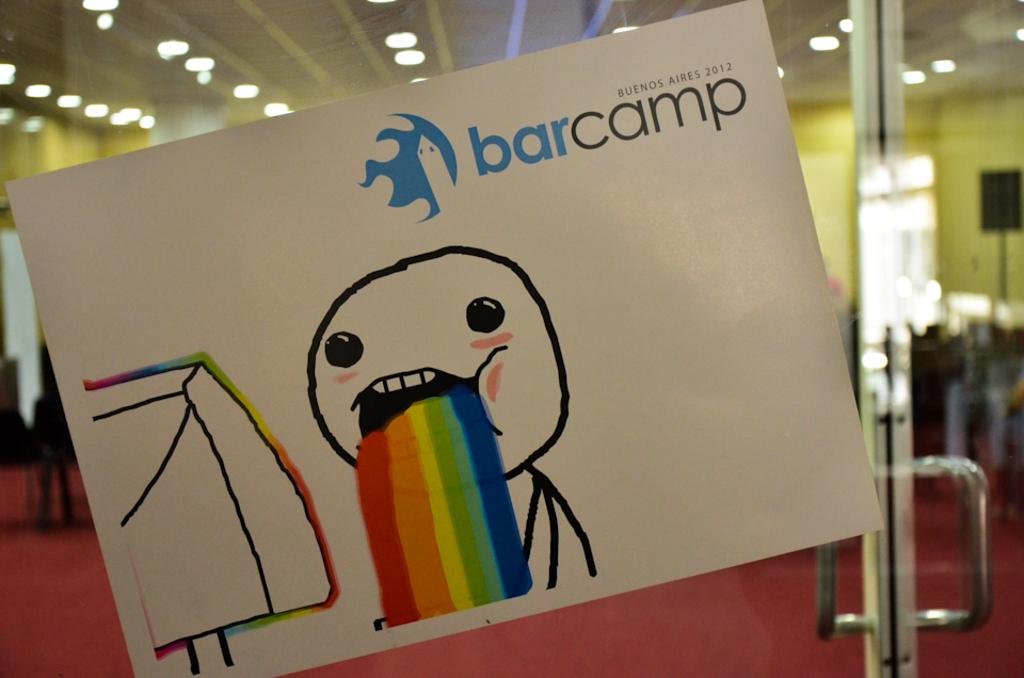Is that a meme?
Keep it short and to the point. Yes. What year was barcamp?
Keep it short and to the point. 2012. 